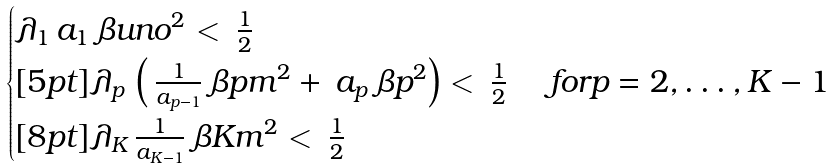Convert formula to latex. <formula><loc_0><loc_0><loc_500><loc_500>\begin{cases} \lambda _ { 1 } \, a _ { 1 } \, \beta u n o ^ { 2 } < \, \frac { 1 } { 2 } \\ [ 5 p t ] \lambda _ { p } \, \left ( \, \frac { 1 } { a _ { p - 1 } } \, \beta p m ^ { 2 } + \, a _ { p } \, \beta p ^ { 2 } \right ) < \, \frac { 1 } { 2 } \ & f o r p = 2 , \dots , K - 1 \\ [ 8 p t ] \lambda _ { K } \, \frac { 1 } { a _ { K - 1 } } \, \beta K m ^ { 2 } < \, \frac { 1 } { 2 } \end{cases}</formula> 